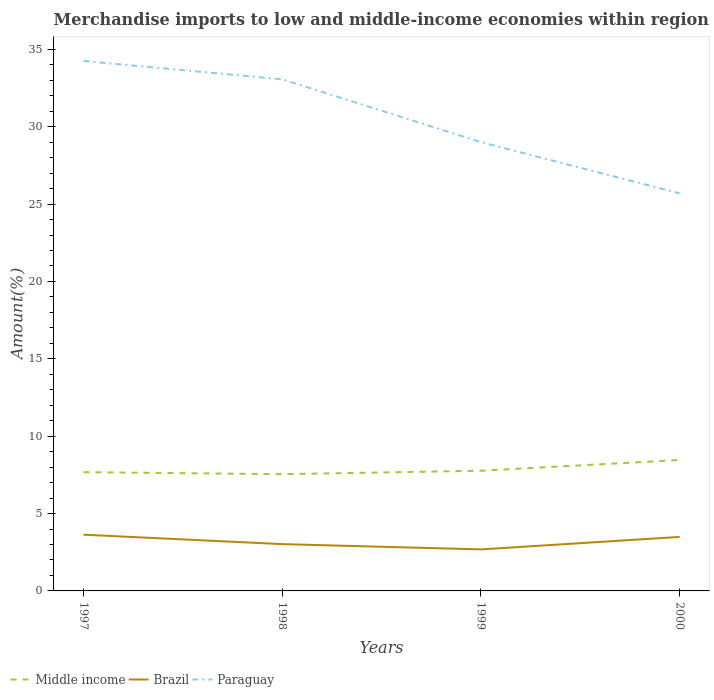How many different coloured lines are there?
Provide a short and direct response. 3. Is the number of lines equal to the number of legend labels?
Provide a succinct answer. Yes. Across all years, what is the maximum percentage of amount earned from merchandise imports in Brazil?
Provide a short and direct response. 2.68. What is the total percentage of amount earned from merchandise imports in Middle income in the graph?
Keep it short and to the point. 0.13. What is the difference between the highest and the second highest percentage of amount earned from merchandise imports in Middle income?
Offer a terse response. 0.92. What is the difference between the highest and the lowest percentage of amount earned from merchandise imports in Paraguay?
Give a very brief answer. 2. Is the percentage of amount earned from merchandise imports in Middle income strictly greater than the percentage of amount earned from merchandise imports in Brazil over the years?
Offer a terse response. No. How many years are there in the graph?
Give a very brief answer. 4. What is the difference between two consecutive major ticks on the Y-axis?
Keep it short and to the point. 5. Does the graph contain any zero values?
Keep it short and to the point. No. Where does the legend appear in the graph?
Offer a very short reply. Bottom left. What is the title of the graph?
Your response must be concise. Merchandise imports to low and middle-income economies within region. What is the label or title of the X-axis?
Ensure brevity in your answer.  Years. What is the label or title of the Y-axis?
Provide a succinct answer. Amount(%). What is the Amount(%) in Middle income in 1997?
Offer a terse response. 7.68. What is the Amount(%) in Brazil in 1997?
Keep it short and to the point. 3.63. What is the Amount(%) in Paraguay in 1997?
Give a very brief answer. 34.25. What is the Amount(%) in Middle income in 1998?
Provide a short and direct response. 7.54. What is the Amount(%) in Brazil in 1998?
Your response must be concise. 3.02. What is the Amount(%) in Paraguay in 1998?
Make the answer very short. 33.06. What is the Amount(%) of Middle income in 1999?
Keep it short and to the point. 7.77. What is the Amount(%) in Brazil in 1999?
Your answer should be very brief. 2.68. What is the Amount(%) of Paraguay in 1999?
Keep it short and to the point. 29. What is the Amount(%) of Middle income in 2000?
Offer a very short reply. 8.46. What is the Amount(%) of Brazil in 2000?
Offer a terse response. 3.49. What is the Amount(%) in Paraguay in 2000?
Make the answer very short. 25.69. Across all years, what is the maximum Amount(%) of Middle income?
Give a very brief answer. 8.46. Across all years, what is the maximum Amount(%) of Brazil?
Provide a short and direct response. 3.63. Across all years, what is the maximum Amount(%) of Paraguay?
Provide a short and direct response. 34.25. Across all years, what is the minimum Amount(%) in Middle income?
Provide a succinct answer. 7.54. Across all years, what is the minimum Amount(%) in Brazil?
Provide a short and direct response. 2.68. Across all years, what is the minimum Amount(%) in Paraguay?
Make the answer very short. 25.69. What is the total Amount(%) in Middle income in the graph?
Offer a terse response. 31.45. What is the total Amount(%) of Brazil in the graph?
Provide a short and direct response. 12.83. What is the total Amount(%) of Paraguay in the graph?
Provide a short and direct response. 122. What is the difference between the Amount(%) in Middle income in 1997 and that in 1998?
Offer a very short reply. 0.13. What is the difference between the Amount(%) in Brazil in 1997 and that in 1998?
Your answer should be compact. 0.61. What is the difference between the Amount(%) of Paraguay in 1997 and that in 1998?
Provide a short and direct response. 1.18. What is the difference between the Amount(%) of Middle income in 1997 and that in 1999?
Offer a terse response. -0.09. What is the difference between the Amount(%) of Brazil in 1997 and that in 1999?
Give a very brief answer. 0.95. What is the difference between the Amount(%) in Paraguay in 1997 and that in 1999?
Your answer should be compact. 5.24. What is the difference between the Amount(%) of Middle income in 1997 and that in 2000?
Offer a very short reply. -0.79. What is the difference between the Amount(%) of Brazil in 1997 and that in 2000?
Provide a short and direct response. 0.14. What is the difference between the Amount(%) in Paraguay in 1997 and that in 2000?
Your answer should be compact. 8.56. What is the difference between the Amount(%) in Middle income in 1998 and that in 1999?
Ensure brevity in your answer.  -0.22. What is the difference between the Amount(%) of Brazil in 1998 and that in 1999?
Offer a terse response. 0.34. What is the difference between the Amount(%) in Paraguay in 1998 and that in 1999?
Your answer should be very brief. 4.06. What is the difference between the Amount(%) in Middle income in 1998 and that in 2000?
Make the answer very short. -0.92. What is the difference between the Amount(%) of Brazil in 1998 and that in 2000?
Offer a terse response. -0.47. What is the difference between the Amount(%) of Paraguay in 1998 and that in 2000?
Your answer should be compact. 7.37. What is the difference between the Amount(%) of Middle income in 1999 and that in 2000?
Keep it short and to the point. -0.69. What is the difference between the Amount(%) of Brazil in 1999 and that in 2000?
Your response must be concise. -0.81. What is the difference between the Amount(%) of Paraguay in 1999 and that in 2000?
Give a very brief answer. 3.31. What is the difference between the Amount(%) of Middle income in 1997 and the Amount(%) of Brazil in 1998?
Provide a succinct answer. 4.65. What is the difference between the Amount(%) in Middle income in 1997 and the Amount(%) in Paraguay in 1998?
Provide a succinct answer. -25.39. What is the difference between the Amount(%) in Brazil in 1997 and the Amount(%) in Paraguay in 1998?
Your response must be concise. -29.43. What is the difference between the Amount(%) in Middle income in 1997 and the Amount(%) in Brazil in 1999?
Your answer should be very brief. 4.99. What is the difference between the Amount(%) in Middle income in 1997 and the Amount(%) in Paraguay in 1999?
Offer a very short reply. -21.33. What is the difference between the Amount(%) of Brazil in 1997 and the Amount(%) of Paraguay in 1999?
Make the answer very short. -25.37. What is the difference between the Amount(%) in Middle income in 1997 and the Amount(%) in Brazil in 2000?
Keep it short and to the point. 4.18. What is the difference between the Amount(%) in Middle income in 1997 and the Amount(%) in Paraguay in 2000?
Ensure brevity in your answer.  -18.01. What is the difference between the Amount(%) in Brazil in 1997 and the Amount(%) in Paraguay in 2000?
Offer a terse response. -22.05. What is the difference between the Amount(%) in Middle income in 1998 and the Amount(%) in Brazil in 1999?
Offer a very short reply. 4.86. What is the difference between the Amount(%) in Middle income in 1998 and the Amount(%) in Paraguay in 1999?
Ensure brevity in your answer.  -21.46. What is the difference between the Amount(%) of Brazil in 1998 and the Amount(%) of Paraguay in 1999?
Give a very brief answer. -25.98. What is the difference between the Amount(%) of Middle income in 1998 and the Amount(%) of Brazil in 2000?
Your response must be concise. 4.05. What is the difference between the Amount(%) in Middle income in 1998 and the Amount(%) in Paraguay in 2000?
Your answer should be compact. -18.14. What is the difference between the Amount(%) of Brazil in 1998 and the Amount(%) of Paraguay in 2000?
Your response must be concise. -22.66. What is the difference between the Amount(%) of Middle income in 1999 and the Amount(%) of Brazil in 2000?
Ensure brevity in your answer.  4.28. What is the difference between the Amount(%) of Middle income in 1999 and the Amount(%) of Paraguay in 2000?
Your response must be concise. -17.92. What is the difference between the Amount(%) of Brazil in 1999 and the Amount(%) of Paraguay in 2000?
Provide a short and direct response. -23. What is the average Amount(%) in Middle income per year?
Your response must be concise. 7.86. What is the average Amount(%) of Brazil per year?
Provide a succinct answer. 3.21. What is the average Amount(%) of Paraguay per year?
Keep it short and to the point. 30.5. In the year 1997, what is the difference between the Amount(%) of Middle income and Amount(%) of Brazil?
Offer a very short reply. 4.04. In the year 1997, what is the difference between the Amount(%) in Middle income and Amount(%) in Paraguay?
Your response must be concise. -26.57. In the year 1997, what is the difference between the Amount(%) in Brazil and Amount(%) in Paraguay?
Offer a terse response. -30.61. In the year 1998, what is the difference between the Amount(%) in Middle income and Amount(%) in Brazil?
Keep it short and to the point. 4.52. In the year 1998, what is the difference between the Amount(%) in Middle income and Amount(%) in Paraguay?
Keep it short and to the point. -25.52. In the year 1998, what is the difference between the Amount(%) in Brazil and Amount(%) in Paraguay?
Your response must be concise. -30.04. In the year 1999, what is the difference between the Amount(%) in Middle income and Amount(%) in Brazil?
Provide a succinct answer. 5.08. In the year 1999, what is the difference between the Amount(%) of Middle income and Amount(%) of Paraguay?
Keep it short and to the point. -21.23. In the year 1999, what is the difference between the Amount(%) in Brazil and Amount(%) in Paraguay?
Your response must be concise. -26.32. In the year 2000, what is the difference between the Amount(%) of Middle income and Amount(%) of Brazil?
Your response must be concise. 4.97. In the year 2000, what is the difference between the Amount(%) of Middle income and Amount(%) of Paraguay?
Offer a terse response. -17.23. In the year 2000, what is the difference between the Amount(%) of Brazil and Amount(%) of Paraguay?
Provide a succinct answer. -22.2. What is the ratio of the Amount(%) of Middle income in 1997 to that in 1998?
Your response must be concise. 1.02. What is the ratio of the Amount(%) in Brazil in 1997 to that in 1998?
Your response must be concise. 1.2. What is the ratio of the Amount(%) of Paraguay in 1997 to that in 1998?
Offer a very short reply. 1.04. What is the ratio of the Amount(%) of Brazil in 1997 to that in 1999?
Ensure brevity in your answer.  1.35. What is the ratio of the Amount(%) in Paraguay in 1997 to that in 1999?
Keep it short and to the point. 1.18. What is the ratio of the Amount(%) of Middle income in 1997 to that in 2000?
Offer a very short reply. 0.91. What is the ratio of the Amount(%) in Brazil in 1997 to that in 2000?
Ensure brevity in your answer.  1.04. What is the ratio of the Amount(%) of Paraguay in 1997 to that in 2000?
Make the answer very short. 1.33. What is the ratio of the Amount(%) in Middle income in 1998 to that in 1999?
Your answer should be compact. 0.97. What is the ratio of the Amount(%) in Brazil in 1998 to that in 1999?
Offer a very short reply. 1.13. What is the ratio of the Amount(%) of Paraguay in 1998 to that in 1999?
Your response must be concise. 1.14. What is the ratio of the Amount(%) of Middle income in 1998 to that in 2000?
Give a very brief answer. 0.89. What is the ratio of the Amount(%) in Brazil in 1998 to that in 2000?
Your answer should be very brief. 0.87. What is the ratio of the Amount(%) in Paraguay in 1998 to that in 2000?
Offer a terse response. 1.29. What is the ratio of the Amount(%) of Middle income in 1999 to that in 2000?
Offer a terse response. 0.92. What is the ratio of the Amount(%) in Brazil in 1999 to that in 2000?
Offer a terse response. 0.77. What is the ratio of the Amount(%) in Paraguay in 1999 to that in 2000?
Provide a short and direct response. 1.13. What is the difference between the highest and the second highest Amount(%) of Middle income?
Give a very brief answer. 0.69. What is the difference between the highest and the second highest Amount(%) in Brazil?
Provide a succinct answer. 0.14. What is the difference between the highest and the second highest Amount(%) in Paraguay?
Give a very brief answer. 1.18. What is the difference between the highest and the lowest Amount(%) in Middle income?
Offer a very short reply. 0.92. What is the difference between the highest and the lowest Amount(%) of Paraguay?
Offer a terse response. 8.56. 